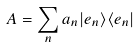<formula> <loc_0><loc_0><loc_500><loc_500>A = \sum _ { n } a _ { n } | e _ { n } \rangle \langle e _ { n } |</formula> 